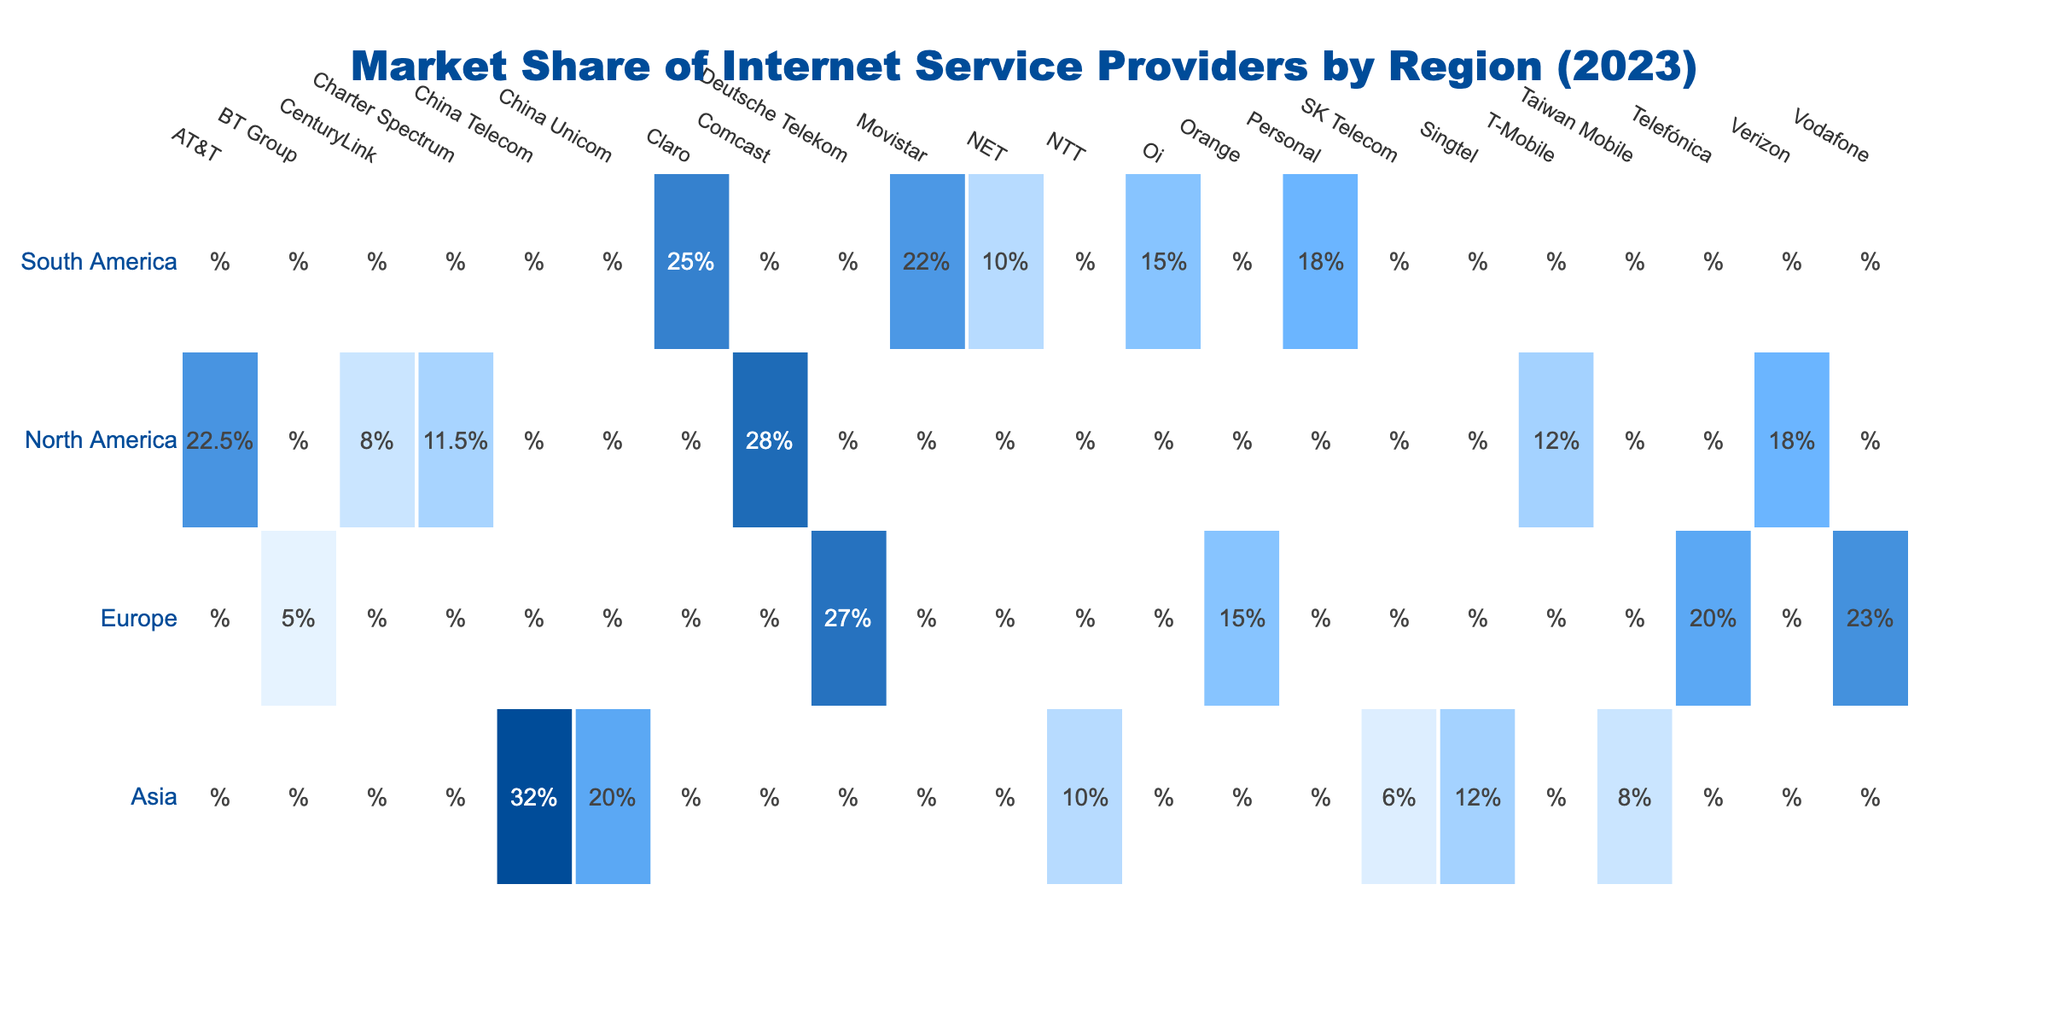What is the market share of Comcast in North America? From the table, under the North America row, the Comcast market share is directly listed as 28.0%.
Answer: 28.0% Which internet service provider has the lowest market share in Europe? Looking at the Europe row, we find that BT Group has the lowest market share, which is 5.0%.
Answer: 5.0% What is the combined market share of internet service providers in South America? To find the combined market share, we add up the market shares: Claro 25.0% + Movistar 22.0% + Oi 15.0% + Personal 18.0% + NET 10.0% = 100.0%.
Answer: 100.0% Is the market share of T-Mobile greater than that of Verizon in North America? In North America, T-Mobile has a market share of 12.0%, while Verizon has 18.0%. Since 12.0% is less than 18.0%, the statement is false.
Answer: No What is the average market share for providers in Asia? The market shares for Asia are: China Telecom 32.0%, China Unicom 20.0%, NTT 10.0%, Singtel 12.0%, Taiwan Mobile 8.0%, SK Telecom 6.0%. The total is 32.0 + 20.0 + 10.0 + 12.0 + 8.0 + 6.0 = 88.0%. To find the average, we divide this by 6 (the number of providers), which gives us 88.0/6 ≈ 14.67%.
Answer: 14.67% Which region has the highest total market share, and what is the value? By looking at the individual total market shares, North America has 100.0%, Europe has 100.0%, Asia has 108.0%, and South America has 100.0%. Therefore, Asia has the highest total market share at 108.0%.
Answer: Asia, 108.0% 